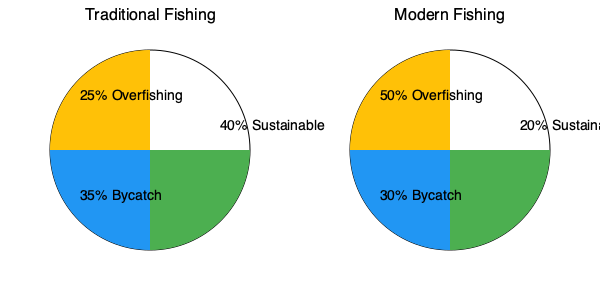Based on the pie charts comparing traditional and modern fishing practices in the Cook Islands, calculate the difference in the percentage of sustainable fishing practices between the two methods. How does this difference impact the overall sustainability of fishing in the region? To solve this problem, we need to follow these steps:

1. Identify the percentage of sustainable fishing for each method:
   - Traditional fishing: 40% sustainable
   - Modern fishing: 20% sustainable

2. Calculate the difference in sustainable fishing percentages:
   $40\% - 20\% = 20\%$

3. Analyze the impact on overall sustainability:
   a) The traditional method has a higher percentage of sustainable fishing practices (40% vs. 20%).
   b) The modern method has a significantly higher percentage of overfishing (50% vs. 25%).
   c) Bycatch is slightly lower in modern fishing (30% vs. 35%), but this small improvement is outweighed by the increase in overfishing.

4. Consider the implications for the Cook Islands:
   a) The 20% difference in sustainable practices suggests that traditional fishing methods are more environmentally friendly.
   b) The higher rate of overfishing in modern practices (50% vs. 25%) poses a greater threat to marine ecosystems and long-term fish populations.
   c) The shift from traditional to modern fishing practices could lead to a decline in overall sustainability, potentially impacting the Cook Islands' marine biodiversity and food security.

5. Conclusion:
   The 20% difference in sustainable fishing practices between traditional and modern methods significantly impacts the overall sustainability of fishing in the Cook Islands. Traditional methods appear to be more sustainable, with lower rates of overfishing and higher rates of sustainable practices, which is crucial for maintaining healthy marine ecosystems and ensuring long-term food security for the island nation.
Answer: 20% difference; traditional methods more sustainable, modern methods threaten marine ecosystems and long-term sustainability. 